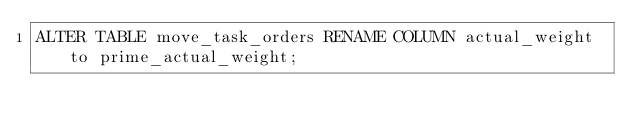<code> <loc_0><loc_0><loc_500><loc_500><_SQL_>ALTER TABLE move_task_orders RENAME COLUMN actual_weight to prime_actual_weight;</code> 